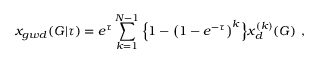Convert formula to latex. <formula><loc_0><loc_0><loc_500><loc_500>x _ { g w d } ( G | \tau ) = e ^ { \tau } \sum _ { k = 1 } ^ { N - 1 } \left \{ 1 - \left ( 1 - e ^ { - \tau } \right ) ^ { k } \right \} x _ { d } ^ { ( k ) } ( G ) \ ,</formula> 